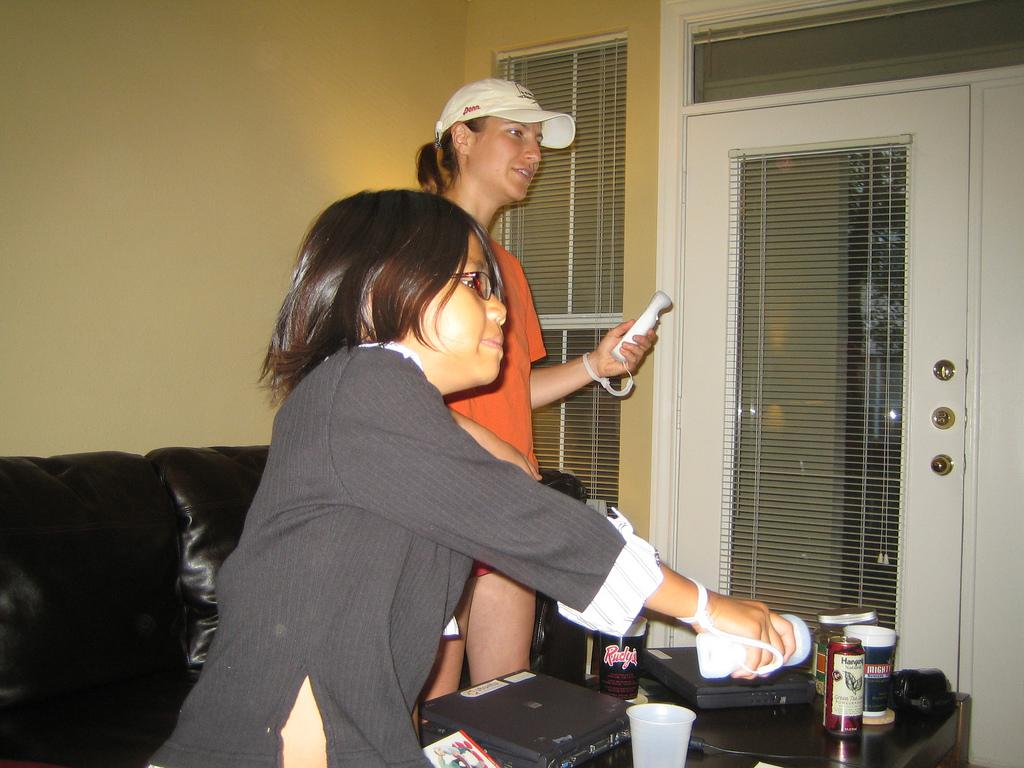Question: what color hat does the woman have on?
Choices:
A. White.
B. Red.
C. Yellow.
D. Green.
Answer with the letter. Answer: A Question: what color are the walls?
Choices:
A. White.
B. Brown.
C. Yellow.
D. Blue.
Answer with the letter. Answer: C Question: what time of day is it?
Choices:
A. The is morning.
B. The time of day is late afternoon.
C. It's midnight.
D. Night.
Answer with the letter. Answer: D Question: why are they standing?
Choices:
A. There are no seats.
B. They are standing in line at the movies.
C. They are playing the national anthem.
D. They are playing games.
Answer with the letter. Answer: D Question: where are the remote controls?
Choices:
A. On the table.
B. In the box.
C. They are holding the remote controls.
D. On their arms.
Answer with the letter. Answer: D Question: when in the day was this picture taken?
Choices:
A. Picture taken in the morning.
B. Late afternoon.
C. Night time.
D. Early evening.
Answer with the letter. Answer: C Question: how many people are pictured?
Choices:
A. One.
B. None.
C. Three.
D. Two.
Answer with the letter. Answer: D Question: what color is the adults shirt?
Choices:
A. Orange.
B. Red.
C. White.
D. Blue.
Answer with the letter. Answer: A Question: where was this photo taken?
Choices:
A. Bathroom.
B. Bedroom.
C. Kitchen.
D. Living room.
Answer with the letter. Answer: D Question: what is on the table?
Choices:
A. A bowl.
B. A bottle.
C. A cup.
D. A bag.
Answer with the letter. Answer: C Question: what is the woman wearing?
Choices:
A. A cap.
B. Glasses.
C. A dress.
D. Shoes.
Answer with the letter. Answer: A Question: what is the girl wearing?
Choices:
A. Glasses.
B. Shoes.
C. A cap.
D. A dress.
Answer with the letter. Answer: C Question: what the people doing?
Choices:
A. Dancing.
B. Talking.
C. Walking.
D. Playing.
Answer with the letter. Answer: D Question: what system are the people playing?
Choices:
A. Playstation 4.
B. Came cube.
C. Atari.
D. Wii.
Answer with the letter. Answer: D 